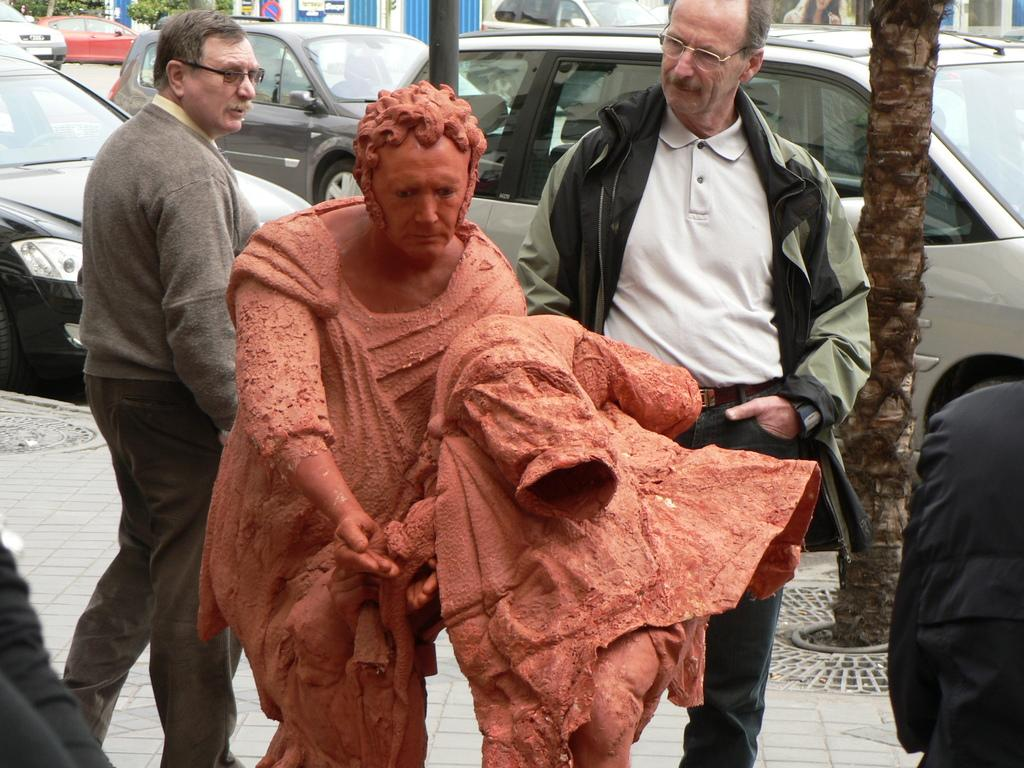What is the main subject of the image? There is a statue in the image. Can you describe the statue's appearance? The statue is brown in color. What can be seen in the background of the image? There are people walking and vehicles visible in the image. What type of vegetation is present in the image? Trees are present in the image. What other structures can be seen in the image? Poles, signboards, and buildings are visible in the image. Can you tell me how many monkeys are climbing the statue in the image? There are no monkeys present in the image; it features a statue without any animals. Is there a fight happening between the people in the background of the image? There is no indication of a fight in the image; people are simply walking in the background. 